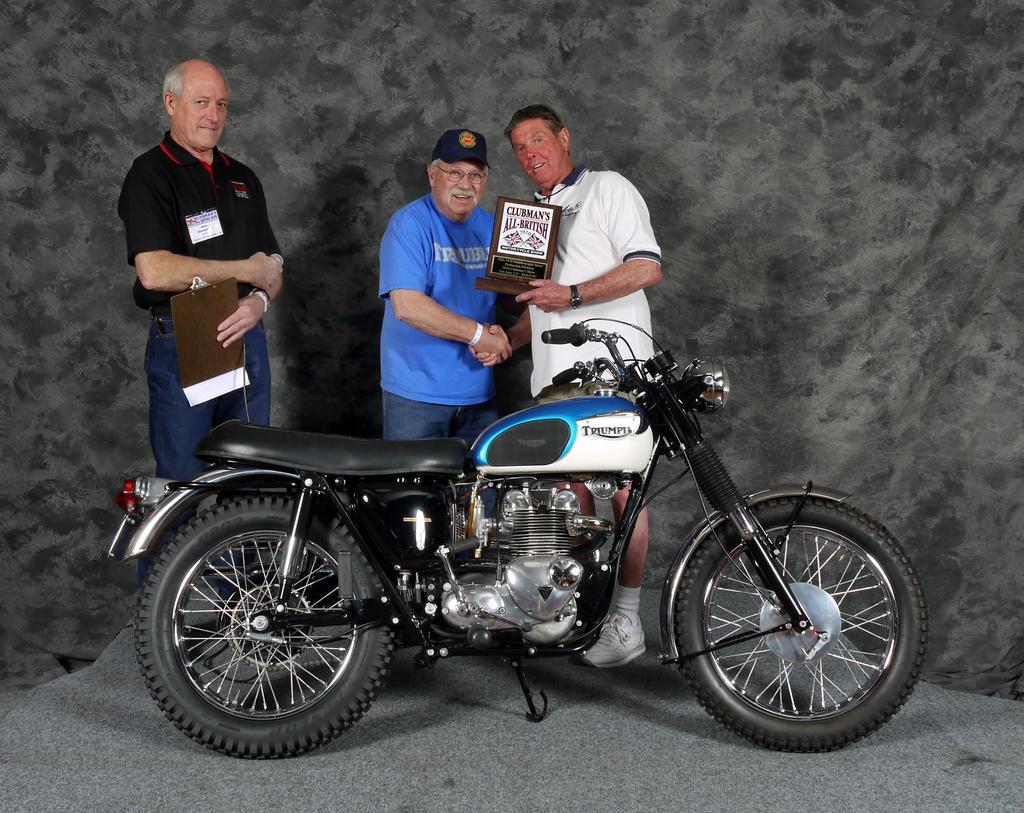Please provide a concise description of this image. In this image there are three people holding an object are standing behind a bike. 